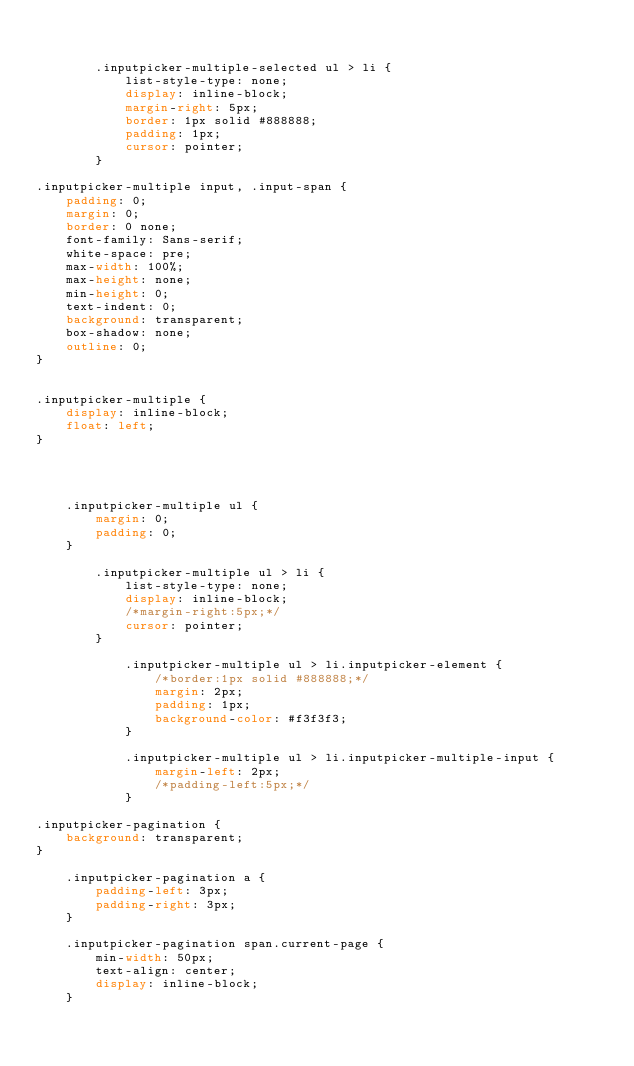<code> <loc_0><loc_0><loc_500><loc_500><_CSS_>

        .inputpicker-multiple-selected ul > li {
            list-style-type: none;
            display: inline-block;
            margin-right: 5px;
            border: 1px solid #888888;
            padding: 1px;
            cursor: pointer;
        }

.inputpicker-multiple input, .input-span {
    padding: 0;
    margin: 0;
    border: 0 none;
    font-family: Sans-serif;
    white-space: pre;
    max-width: 100%;
    max-height: none;
    min-height: 0;
    text-indent: 0;
    background: transparent;
    box-shadow: none;
    outline: 0;
}


.inputpicker-multiple {
    display: inline-block;
    float: left;
}




    .inputpicker-multiple ul {
        margin: 0;
        padding: 0;
    }

        .inputpicker-multiple ul > li {
            list-style-type: none;
            display: inline-block;
            /*margin-right:5px;*/
            cursor: pointer;
        }

            .inputpicker-multiple ul > li.inputpicker-element {
                /*border:1px solid #888888;*/
                margin: 2px;
                padding: 1px;
                background-color: #f3f3f3;
            }

            .inputpicker-multiple ul > li.inputpicker-multiple-input {
                margin-left: 2px;
                /*padding-left:5px;*/
            }

.inputpicker-pagination {
    background: transparent;
}

    .inputpicker-pagination a {
        padding-left: 3px;
        padding-right: 3px;
    }

    .inputpicker-pagination span.current-page {
        min-width: 50px;
        text-align: center;
        display: inline-block;
    }
</code> 